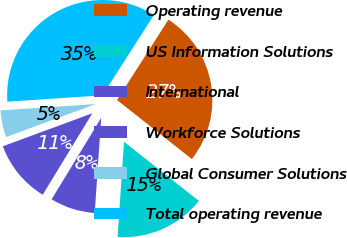Convert chart. <chart><loc_0><loc_0><loc_500><loc_500><pie_chart><fcel>Operating revenue<fcel>US Information Solutions<fcel>International<fcel>Workforce Solutions<fcel>Global Consumer Solutions<fcel>Total operating revenue<nl><fcel>26.57%<fcel>15.45%<fcel>7.62%<fcel>10.68%<fcel>4.56%<fcel>35.12%<nl></chart> 